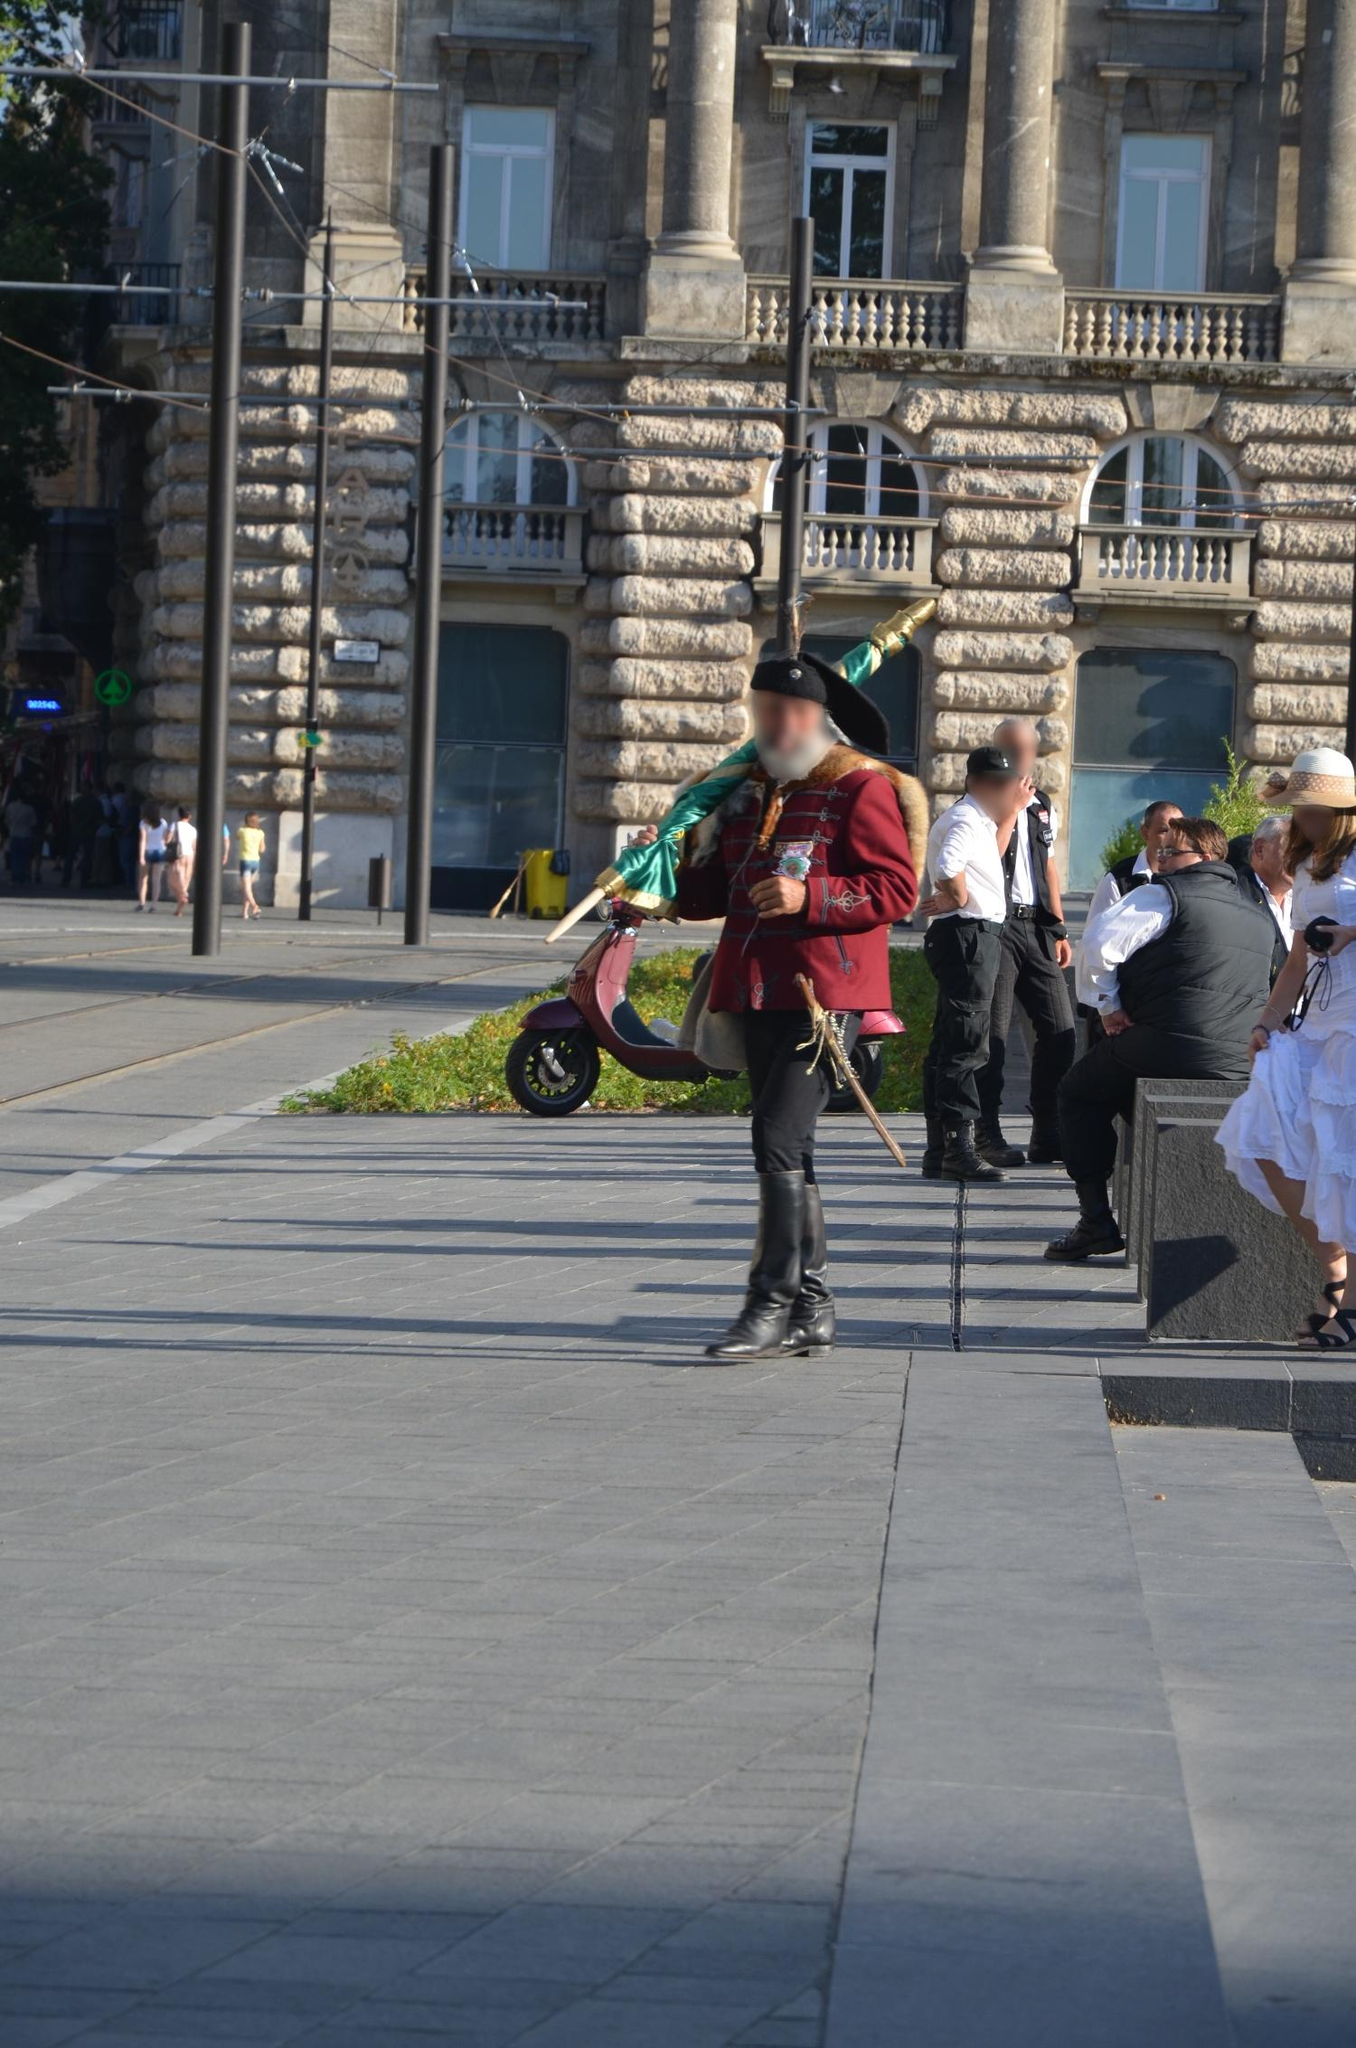Can you describe the significance of the attire worn by the man in the image? The man is wearing a traditional Hungarian Hussar uniform, which is historically significant as it was worn by the Hussars, light cavalry units that originated in Hungary in the 15th century. The attire is not only a symbol of historical military importance but has also become an emblem of national pride and cultural heritage, often worn during parades and other ceremonial occasions. The detailed embroidery, vibrant colors, and accessories like the feathered hat contribute to its distinction and elegance, which captures attention and respects Hungarian history. 